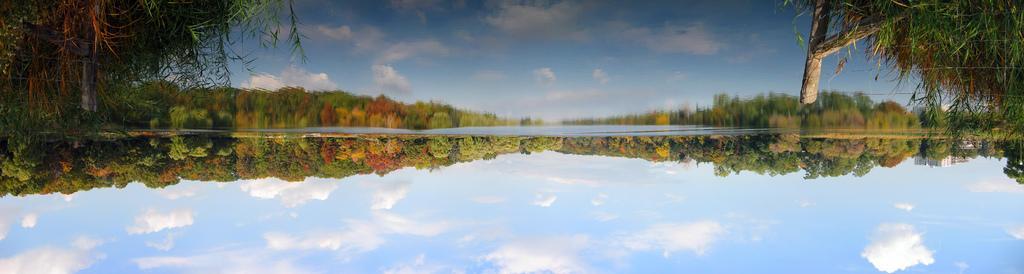How would you summarize this image in a sentence or two? In this image we can see a group of trees and the sky. In the foreground we can see the water. In the water we can see the reflection of trees and the sky. 